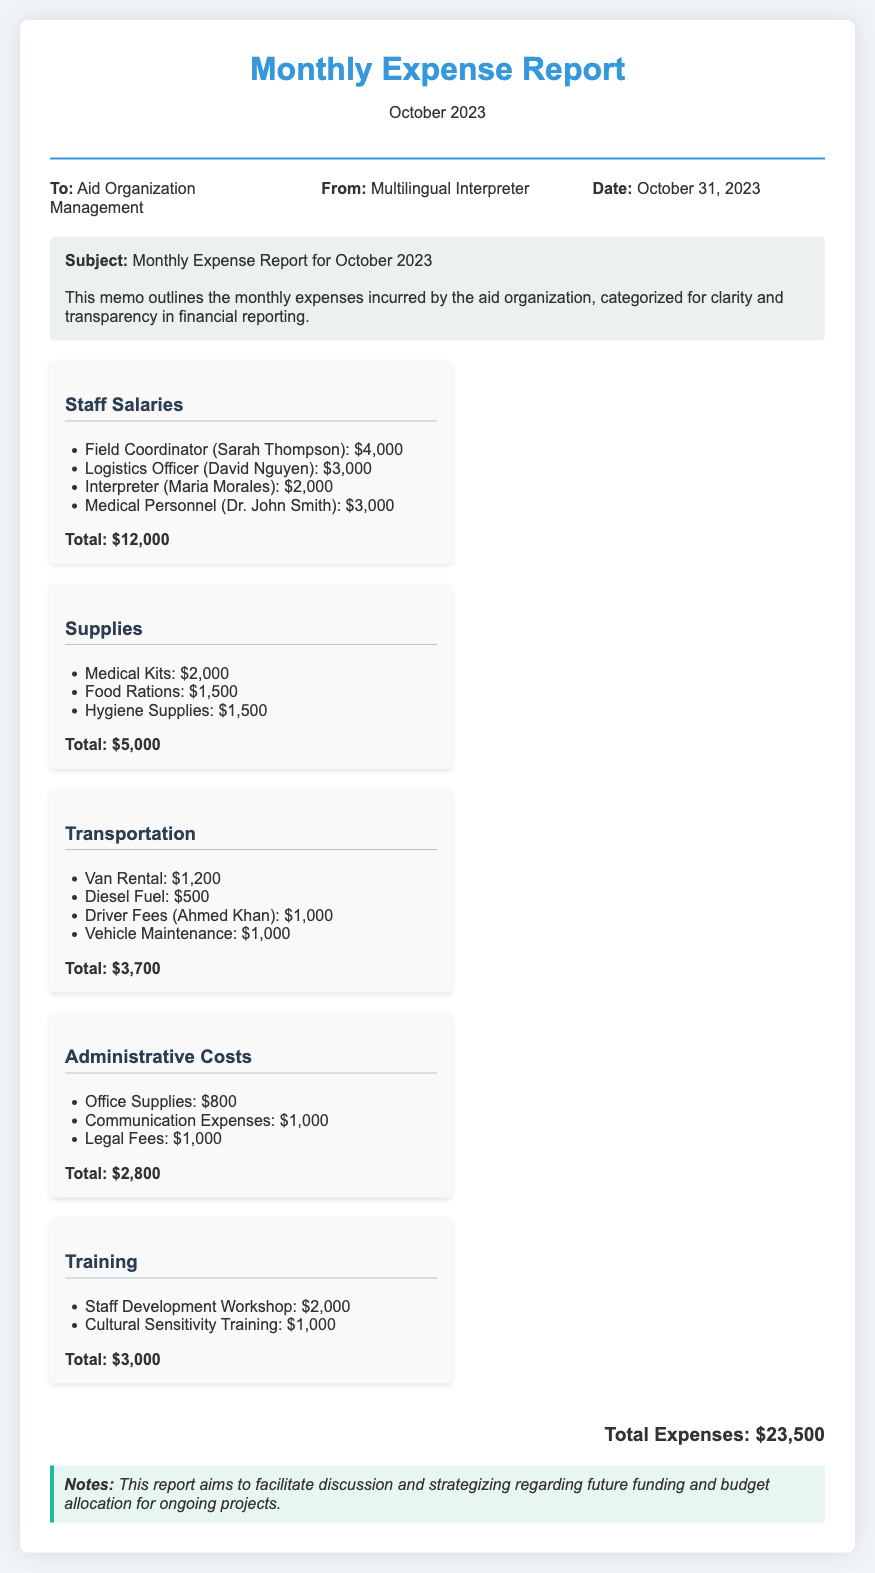what is the total amount spent on Staff Salaries? The total amount for Staff Salaries can be found in the corresponding section, which lists the individual salaries totaling $12,000.
Answer: $12,000 how much was spent on Supplies? The Supplies category shows the total expenses incurred for items such as medical kits and food rations, which is indicated as $5,000.
Answer: $5,000 who is the Field Coordinator? The Field Coordinator is listed in the Staff Salaries section, where Sarah Thompson's name is mentioned.
Answer: Sarah Thompson what is the total cost for Transportation? By reviewing the Transportation expenses, the total amount for this category is identified as $3,700.
Answer: $3,700 how much was allocated for Training? The report details Expenses for Training, which sums up to a total of $3,000.
Answer: $3,000 what is the date of this memo? The memo specifies the date of issuance as October 31, 2023, in the meta section.
Answer: October 31, 2023 what is the note regarding the report? The notes section includes a brief explanation of the report’s intent regarding future funding and budget allocation discussions.
Answer: Future funding and budget allocation how many staff members’ salaries are listed? The document enumerates the salaries of four staff members in the Staff Salaries section.
Answer: Four what was the total expense for Administrative Costs? The total for Administrative Costs is clearly stated in the respective category, amounting to $2,800.
Answer: $2,800 